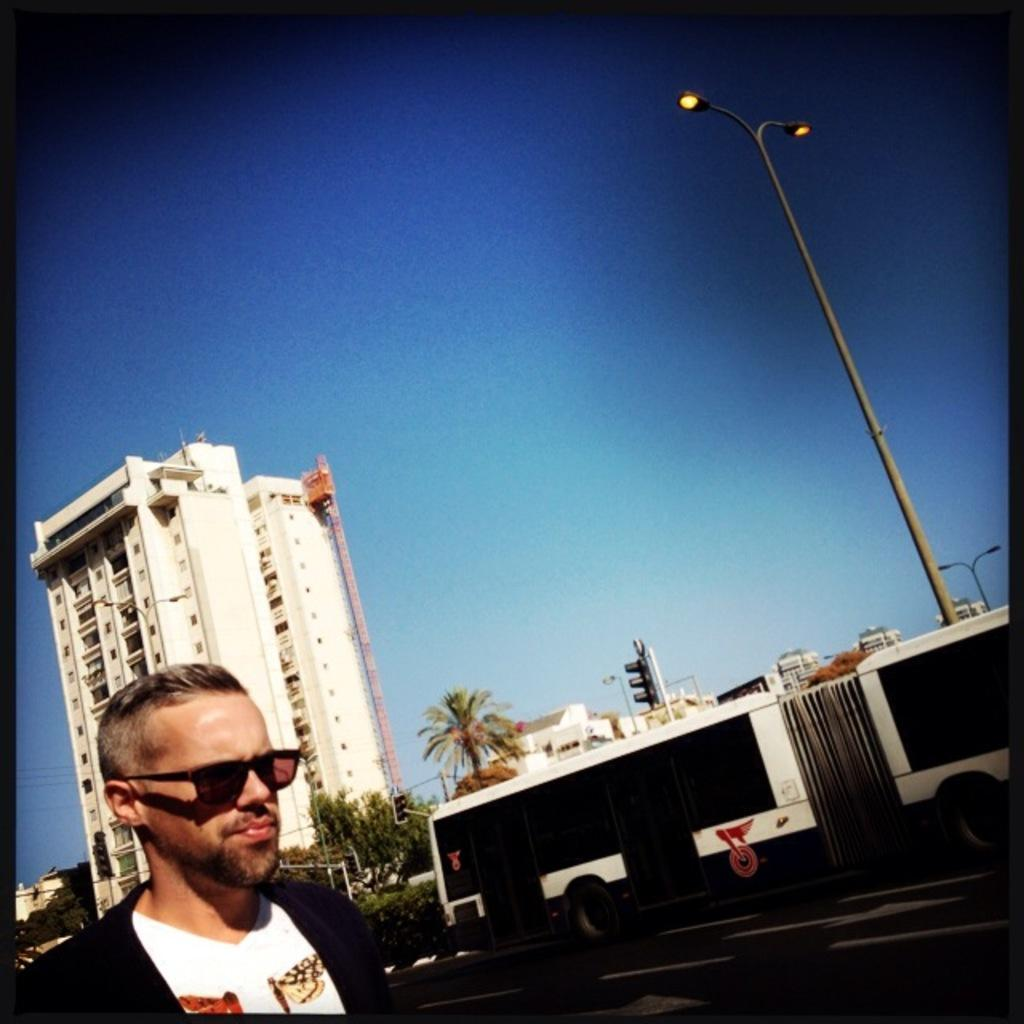Where is the person located in the image? The person is in the bottom left side of the image. What mode of transportation can be seen in the image? There is a bus in the image. What type of structures are present in the image? There are buildings in the image. What other objects can be seen in the image? There are poles and trees in the image. What is visible in the background of the image? The sky is visible in the background of the image. What type of tomatoes are being used to create a rhythm in the image? There are no tomatoes or any indication of rhythm present in the image. 